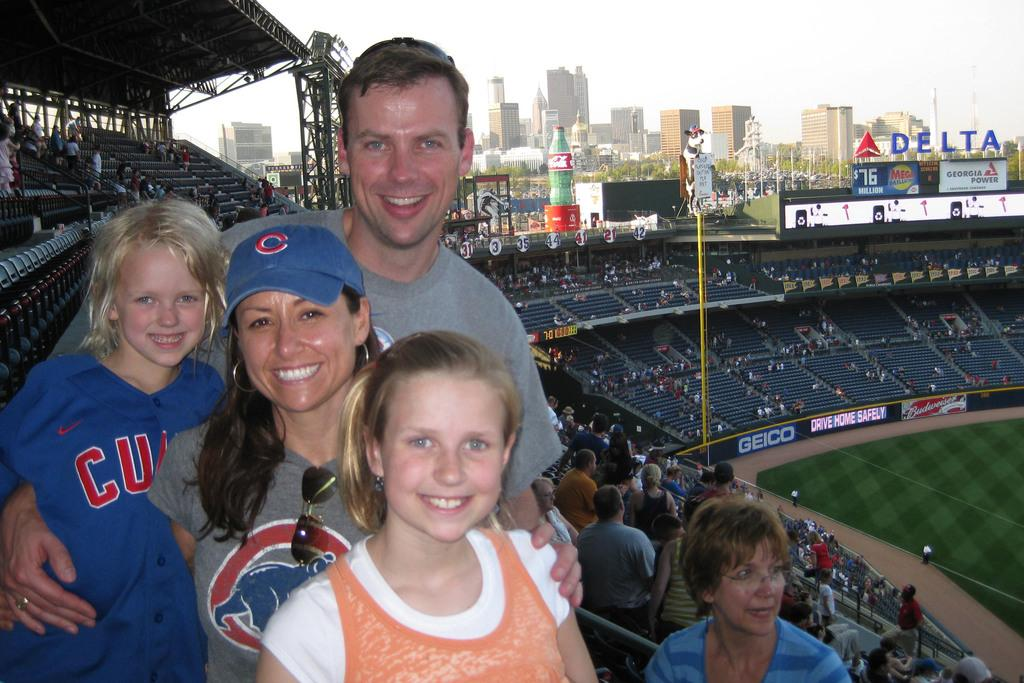<image>
Summarize the visual content of the image. Family posing at the camera at a baseball game for the Chicago Cubs 